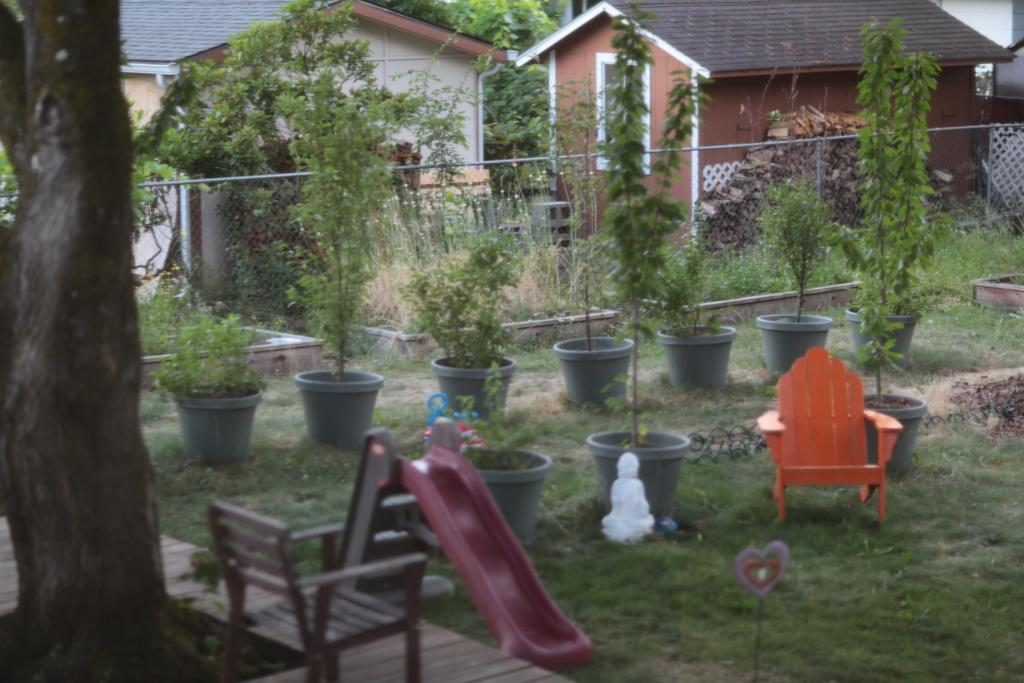What type of furniture is present in the image? There is a chair in the image. What other object can be seen in the image? There is a flower pot in the image. What type of structure is visible in the image? There is a house in the image. Where is the straw located in the image? There is no straw present in the image. What type of heart can be seen in the image? There is no heart present in the image. 